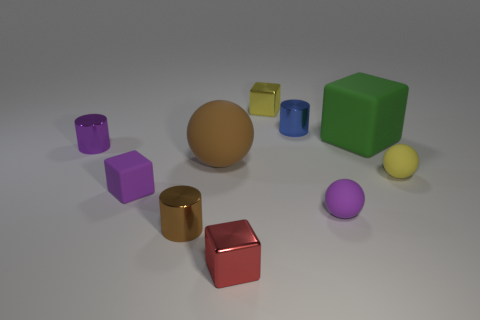Subtract all purple cylinders. How many cylinders are left? 2 Subtract all purple balls. How many balls are left? 2 Subtract all cylinders. How many objects are left? 7 Subtract 0 red cylinders. How many objects are left? 10 Subtract 1 cylinders. How many cylinders are left? 2 Subtract all green balls. Subtract all purple cylinders. How many balls are left? 3 Subtract all red objects. Subtract all small blue metallic objects. How many objects are left? 8 Add 6 small purple matte blocks. How many small purple matte blocks are left? 7 Add 7 yellow metal blocks. How many yellow metal blocks exist? 8 